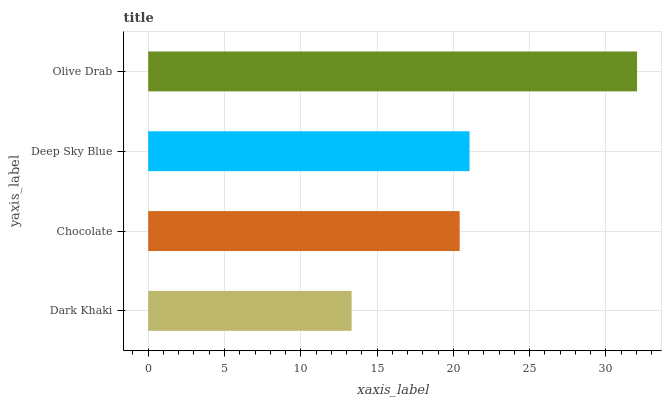Is Dark Khaki the minimum?
Answer yes or no. Yes. Is Olive Drab the maximum?
Answer yes or no. Yes. Is Chocolate the minimum?
Answer yes or no. No. Is Chocolate the maximum?
Answer yes or no. No. Is Chocolate greater than Dark Khaki?
Answer yes or no. Yes. Is Dark Khaki less than Chocolate?
Answer yes or no. Yes. Is Dark Khaki greater than Chocolate?
Answer yes or no. No. Is Chocolate less than Dark Khaki?
Answer yes or no. No. Is Deep Sky Blue the high median?
Answer yes or no. Yes. Is Chocolate the low median?
Answer yes or no. Yes. Is Dark Khaki the high median?
Answer yes or no. No. Is Olive Drab the low median?
Answer yes or no. No. 